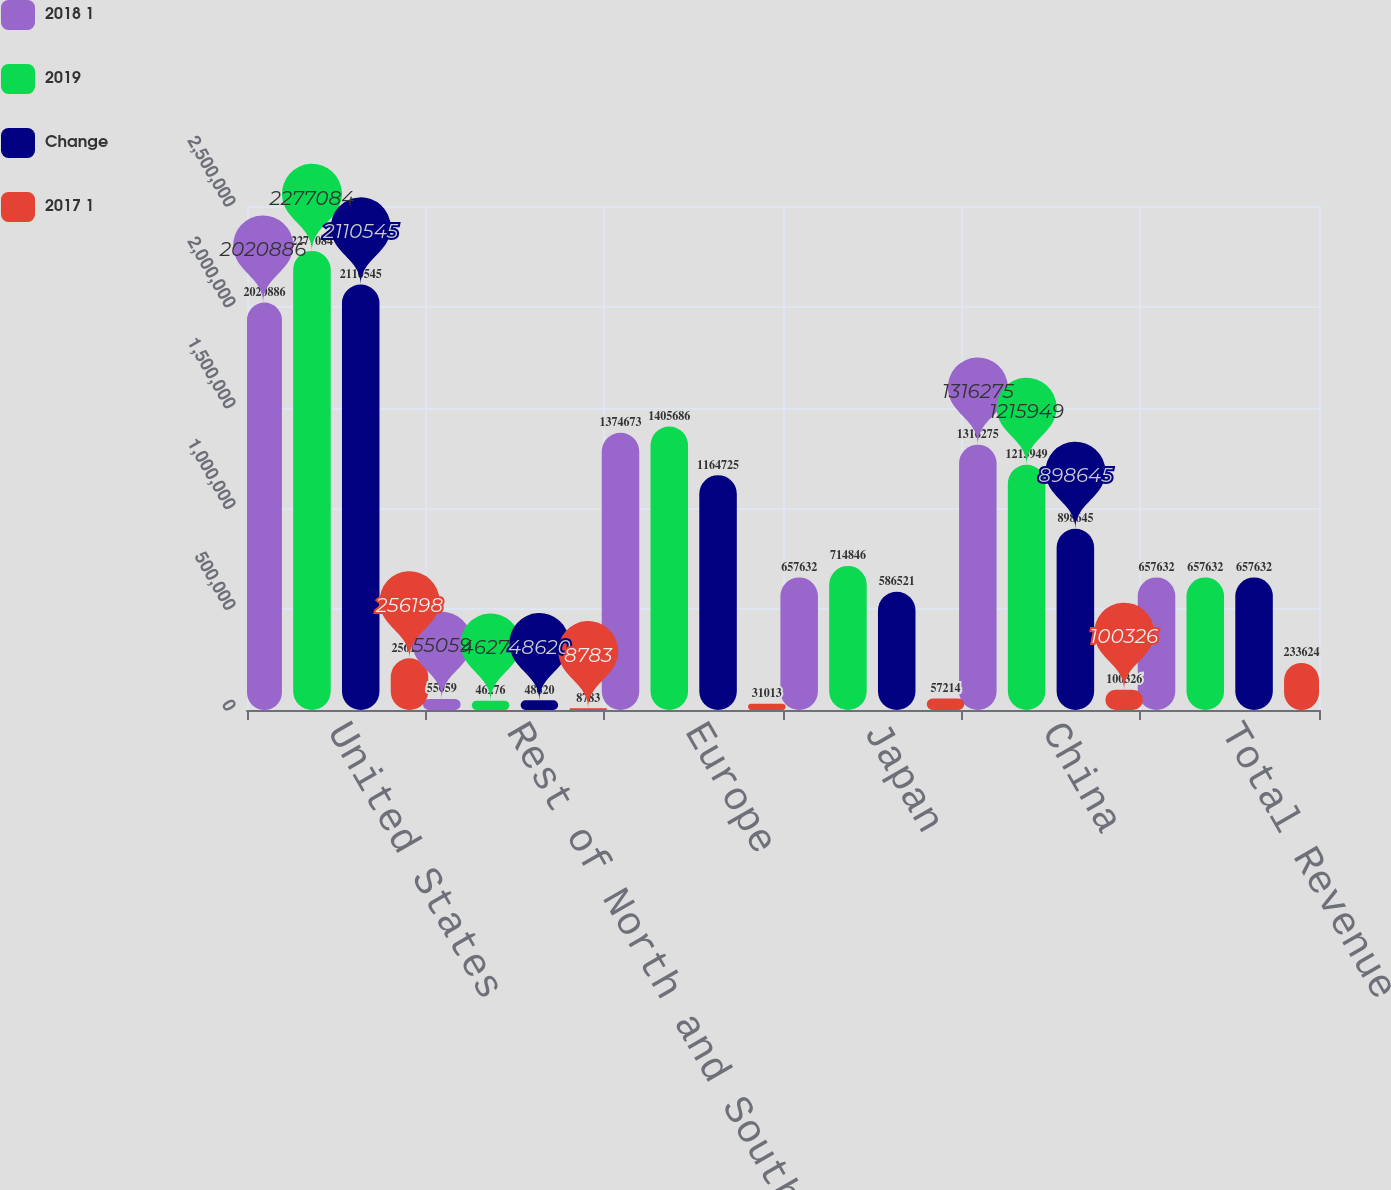<chart> <loc_0><loc_0><loc_500><loc_500><stacked_bar_chart><ecel><fcel>United States<fcel>Rest of North and South<fcel>Europe<fcel>Japan<fcel>China<fcel>Total Revenue<nl><fcel>2018 1<fcel>2.02089e+06<fcel>55059<fcel>1.37467e+06<fcel>657632<fcel>1.31628e+06<fcel>657632<nl><fcel>2019<fcel>2.27708e+06<fcel>46276<fcel>1.40569e+06<fcel>714846<fcel>1.21595e+06<fcel>657632<nl><fcel>Change<fcel>2.11054e+06<fcel>48620<fcel>1.16472e+06<fcel>586521<fcel>898645<fcel>657632<nl><fcel>2017 1<fcel>256198<fcel>8783<fcel>31013<fcel>57214<fcel>100326<fcel>233624<nl></chart> 